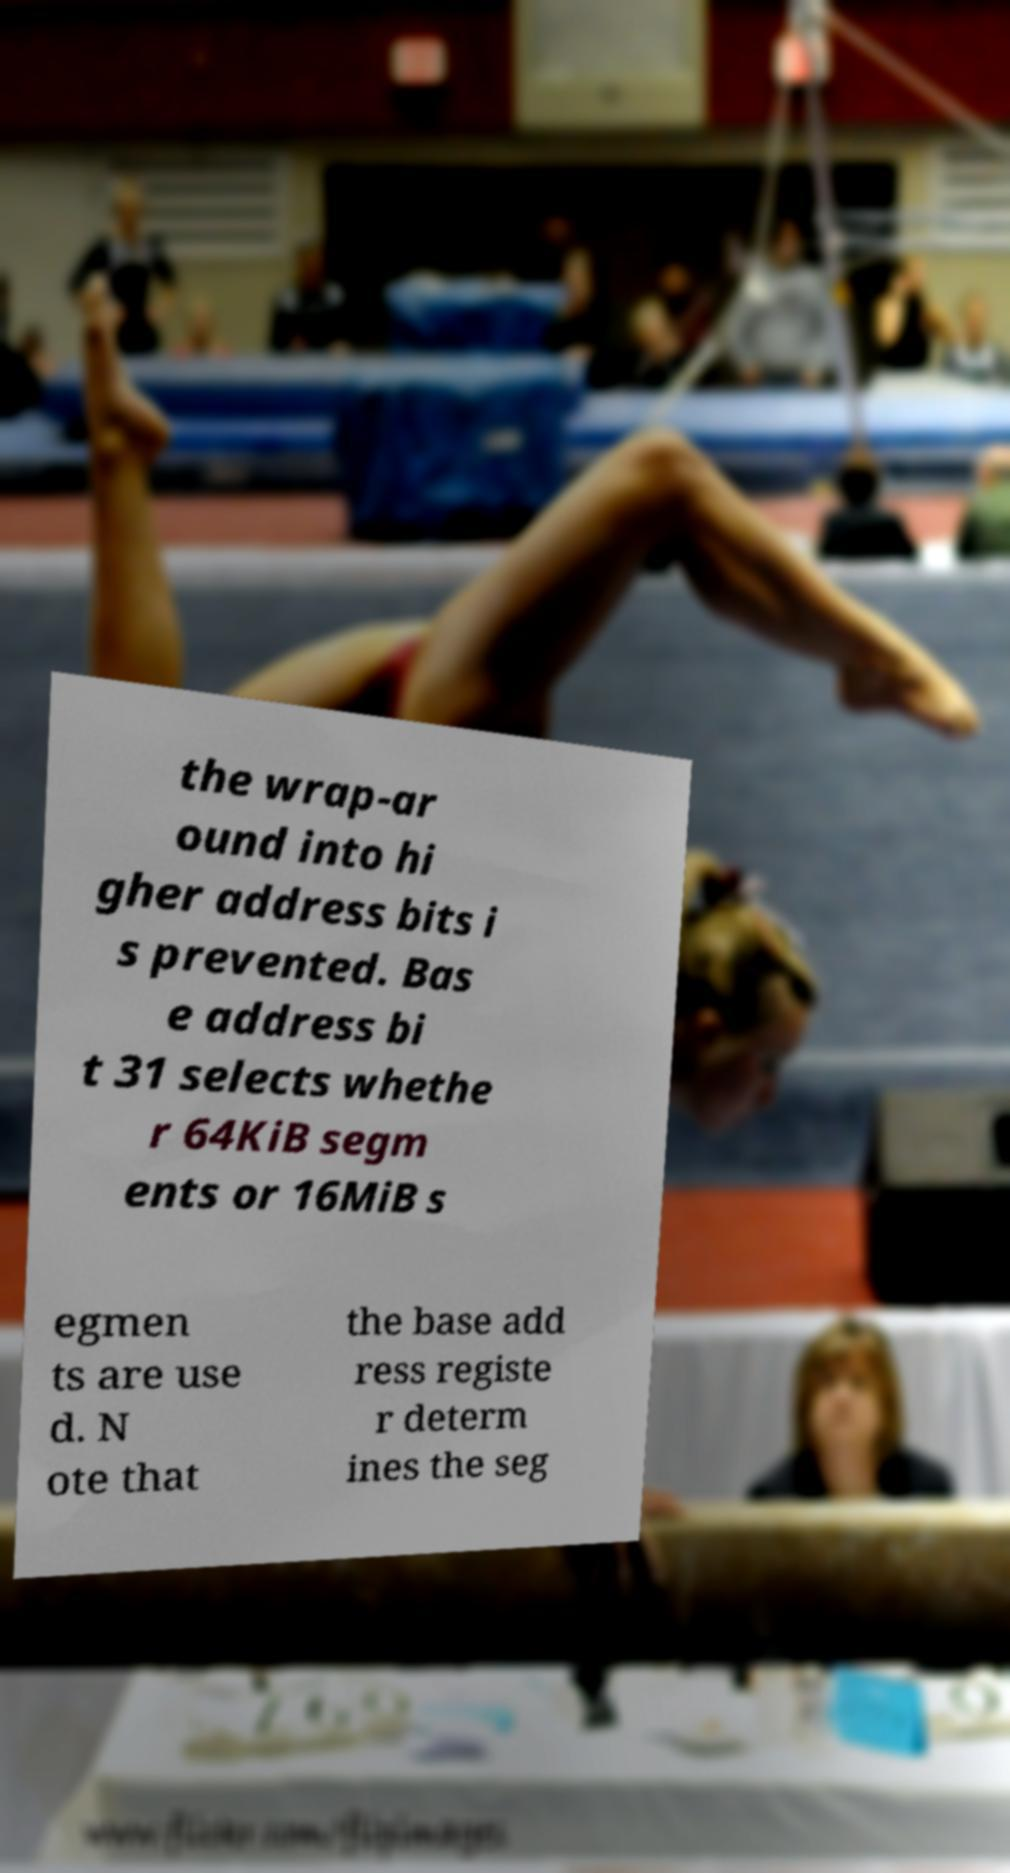Could you assist in decoding the text presented in this image and type it out clearly? the wrap-ar ound into hi gher address bits i s prevented. Bas e address bi t 31 selects whethe r 64KiB segm ents or 16MiB s egmen ts are use d. N ote that the base add ress registe r determ ines the seg 